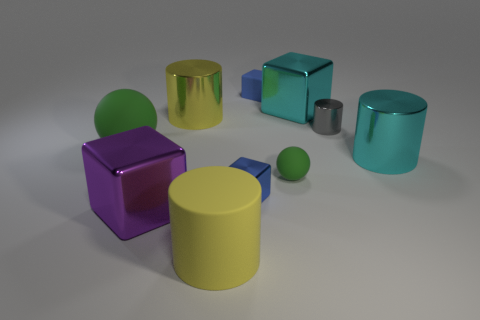Subtract all tiny blue rubber cubes. How many cubes are left? 3 Subtract all green cubes. How many yellow cylinders are left? 2 Subtract 1 cylinders. How many cylinders are left? 3 Subtract all gray cylinders. How many cylinders are left? 3 Subtract 0 gray balls. How many objects are left? 10 Subtract all blocks. How many objects are left? 6 Subtract all gray blocks. Subtract all cyan spheres. How many blocks are left? 4 Subtract all big purple shiny things. Subtract all yellow objects. How many objects are left? 7 Add 8 tiny blue rubber things. How many tiny blue rubber things are left? 9 Add 2 big metallic cylinders. How many big metallic cylinders exist? 4 